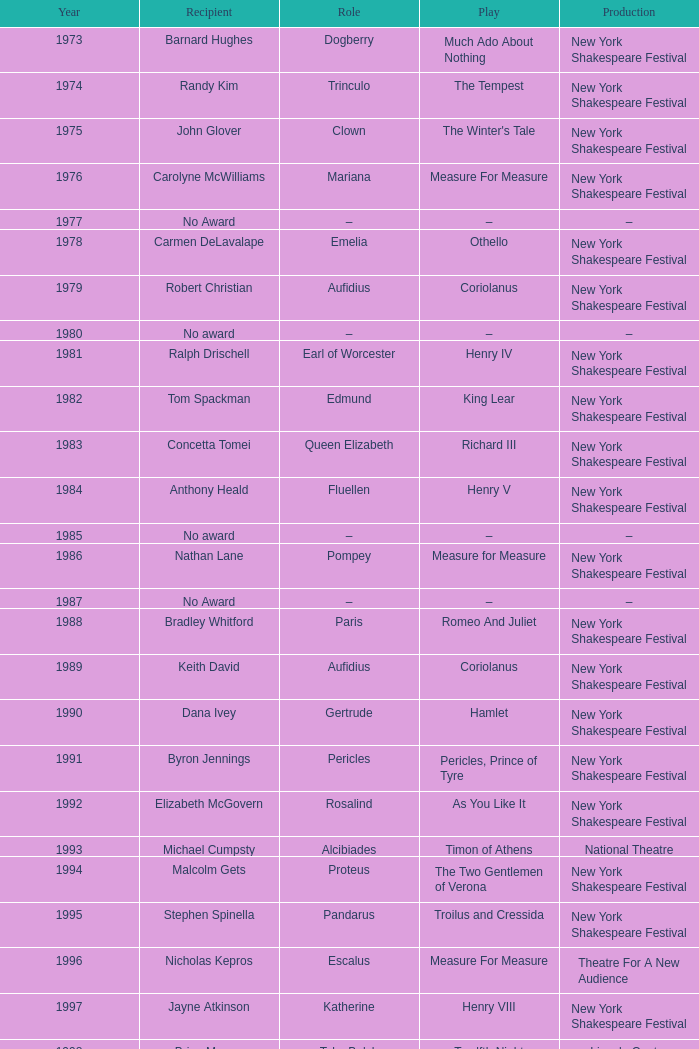Name the play for 1976 Measure For Measure. 